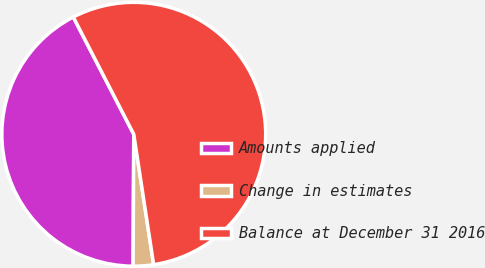Convert chart. <chart><loc_0><loc_0><loc_500><loc_500><pie_chart><fcel>Amounts applied<fcel>Change in estimates<fcel>Balance at December 31 2016<nl><fcel>42.34%<fcel>2.49%<fcel>55.17%<nl></chart> 